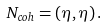Convert formula to latex. <formula><loc_0><loc_0><loc_500><loc_500>N _ { c o h } = ( \eta , \eta ) \, .</formula> 